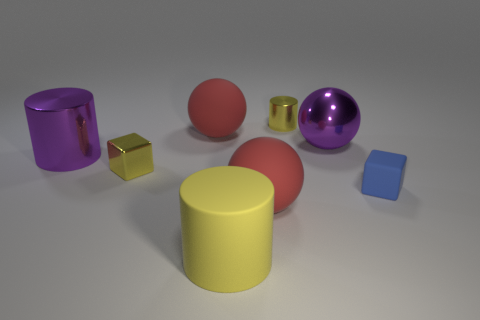The tiny thing behind the red object to the left of the big yellow object is what color?
Give a very brief answer. Yellow. Are there any yellow cylinders that have the same size as the metal ball?
Your response must be concise. Yes. What is the big sphere on the left side of the matte object that is in front of the large rubber object on the right side of the big yellow cylinder made of?
Your answer should be compact. Rubber. There is a cylinder that is behind the purple shiny sphere; how many yellow shiny objects are to the left of it?
Provide a succinct answer. 1. Does the red matte sphere to the left of the yellow matte cylinder have the same size as the large purple cylinder?
Offer a terse response. Yes. How many yellow rubber things are the same shape as the tiny blue thing?
Provide a succinct answer. 0. The yellow matte thing is what shape?
Your answer should be compact. Cylinder. Is the number of cubes that are on the left side of the purple shiny sphere the same as the number of metallic objects?
Give a very brief answer. No. Are the big red ball that is behind the tiny blue block and the purple sphere made of the same material?
Give a very brief answer. No. Are there fewer large red rubber things to the left of the small yellow cube than rubber spheres?
Your response must be concise. Yes. 